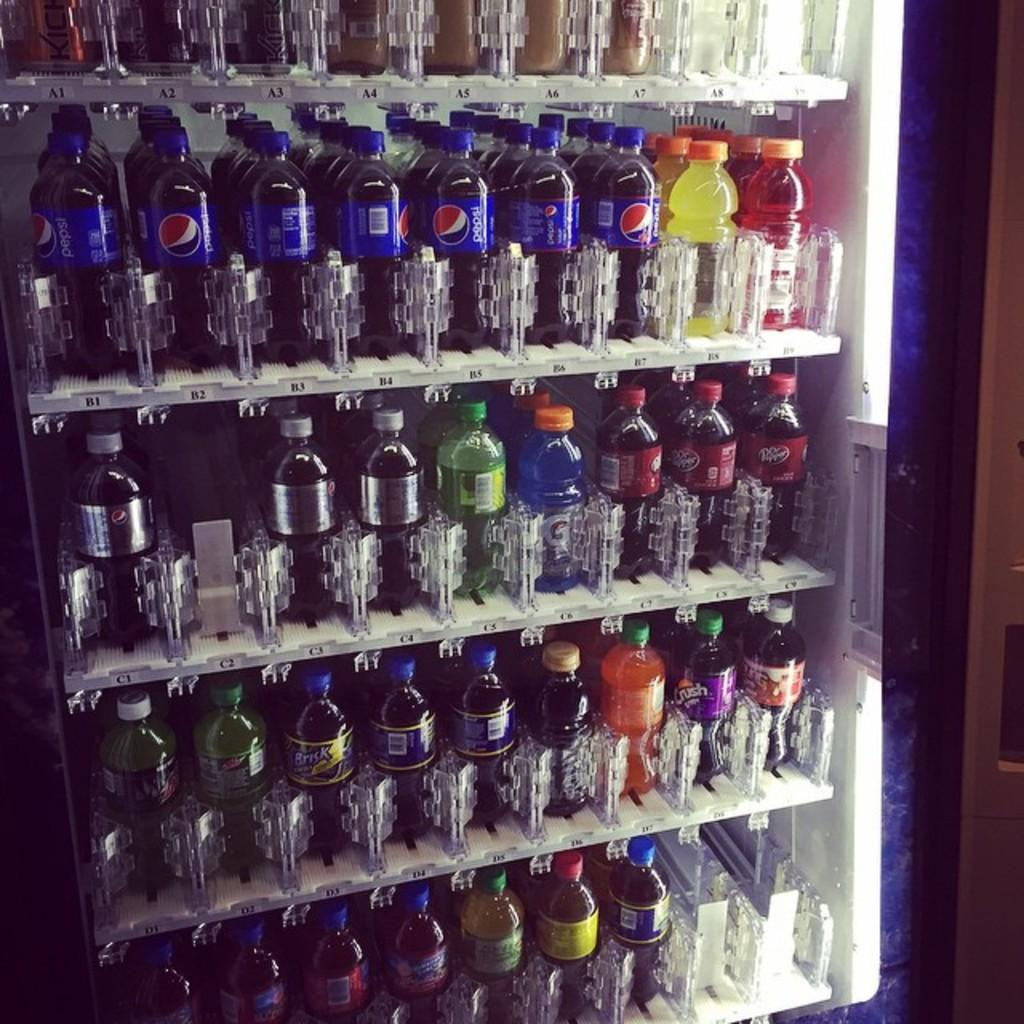What type of bottles are visible in the image? There are preservative drinking bottles in the image. Where are the bottles located in the image? The bottles are arranged in a refrigerator. What type of art can be seen on the road in the image? There is no art or road present in the image; it only features preservative drinking bottles arranged in a refrigerator. 